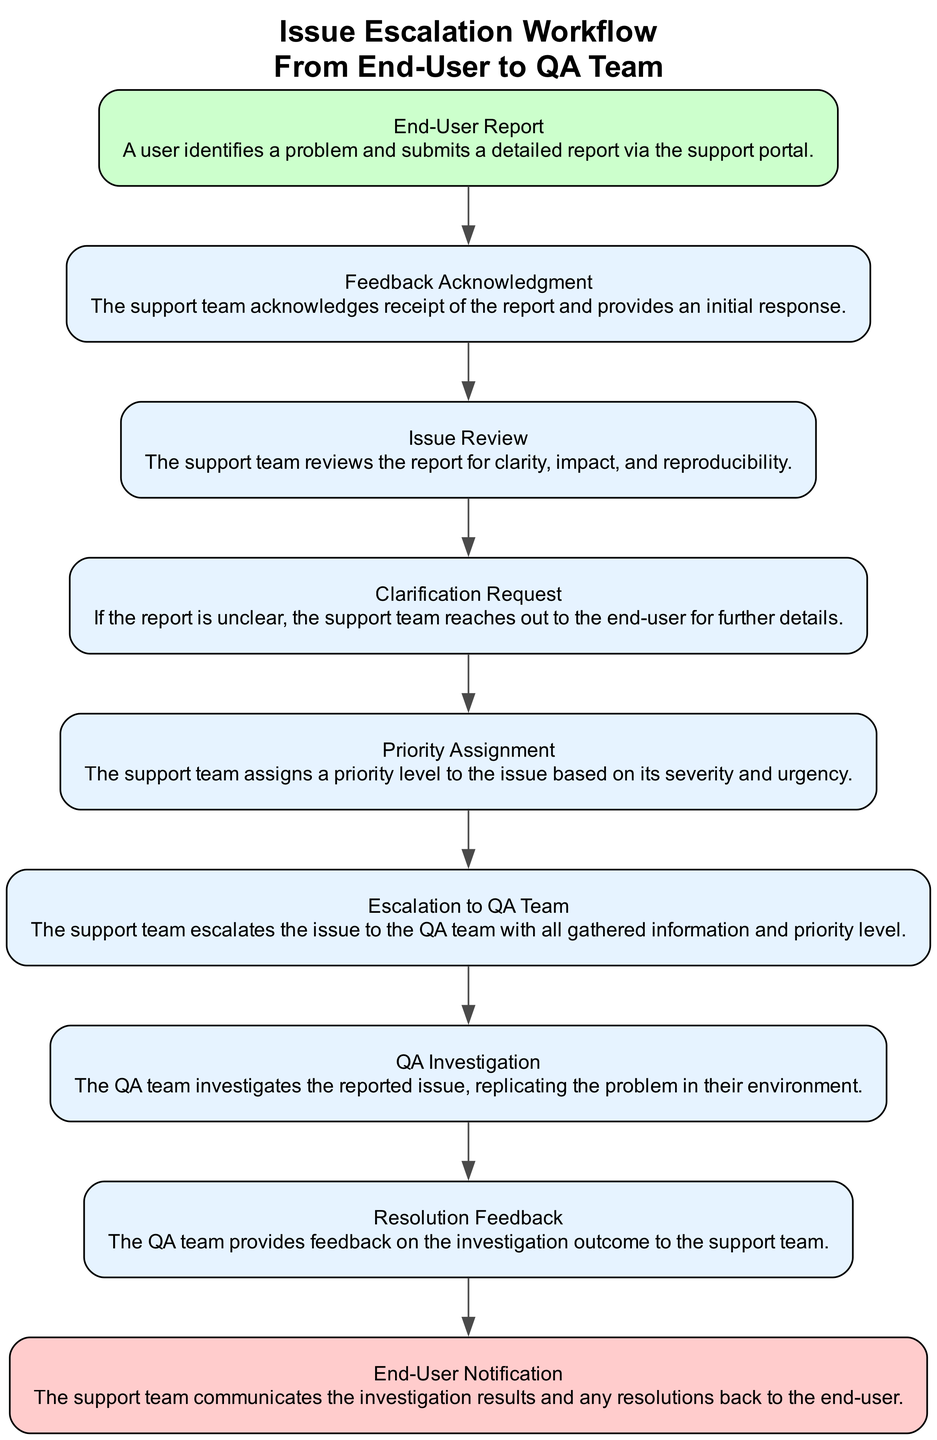What is the first step in the workflow? The first step in the workflow is the "End-User Report," which is where the user identifies a problem and submits a detailed report via the support portal.
Answer: End-User Report How many nodes are present in the flowchart? By counting each unique step from "End-User Report" to "End-User Notification," we can see that there are nine distinct nodes in the flowchart representing the various steps in the issue escalation process.
Answer: Nine What happens after the "Issue Review"? After the "Issue Review," if the report is unclear, the next step is the "Clarification Request," where the support team reaches out to the end-user for additional details.
Answer: Clarification Request Which node communicates with the end-user? The "End-User Notification" communicates the investigation results and any resolutions back to the end-user at the end of the process.
Answer: End-User Notification What is the relationship between "Priority Assignment" and "Escalation to QA Team"? The "Priority Assignment" happens before the "Escalation to QA Team" step since the support team must assign a priority level based on severity and urgency before escalating the issue.
Answer: Prior step What is the primary purpose of the "QA Investigation"? The primary purpose of the "QA Investigation" is to allow the QA team to replicate the reported issue in their environment to understand and address the problem effectively.
Answer: Investigate the reported issue What step follows after "Resolution Feedback"? Once the "Resolution Feedback" has been provided by the QA team regarding the investigation outcome, the next step is the "End-User Notification," where the results and resolutions are communicated to the end-user.
Answer: End-User Notification How many steps involve direct communication to the end-user? There are two steps that involve direct communication to the end-user: the "End-User Report" where they report the problem and the "End-User Notification" where they are informed of the resolution.
Answer: Two What kind of information is escalated to the QA team? The support team escalates the issue to the QA team along with all gathered information and the priority level assigned to it, ensuring that the QA team has the necessary context to address the problem.
Answer: All gathered information and priority level What does the term "Feedback Acknowledgment" refer to in the workflow? "Feedback Acknowledgment" refers to the step where the support team acknowledges receipt of the report and provides an initial response to the end-user, confirming that their report has been received and is being acted upon.
Answer: Acknowledgment of receipt of report 